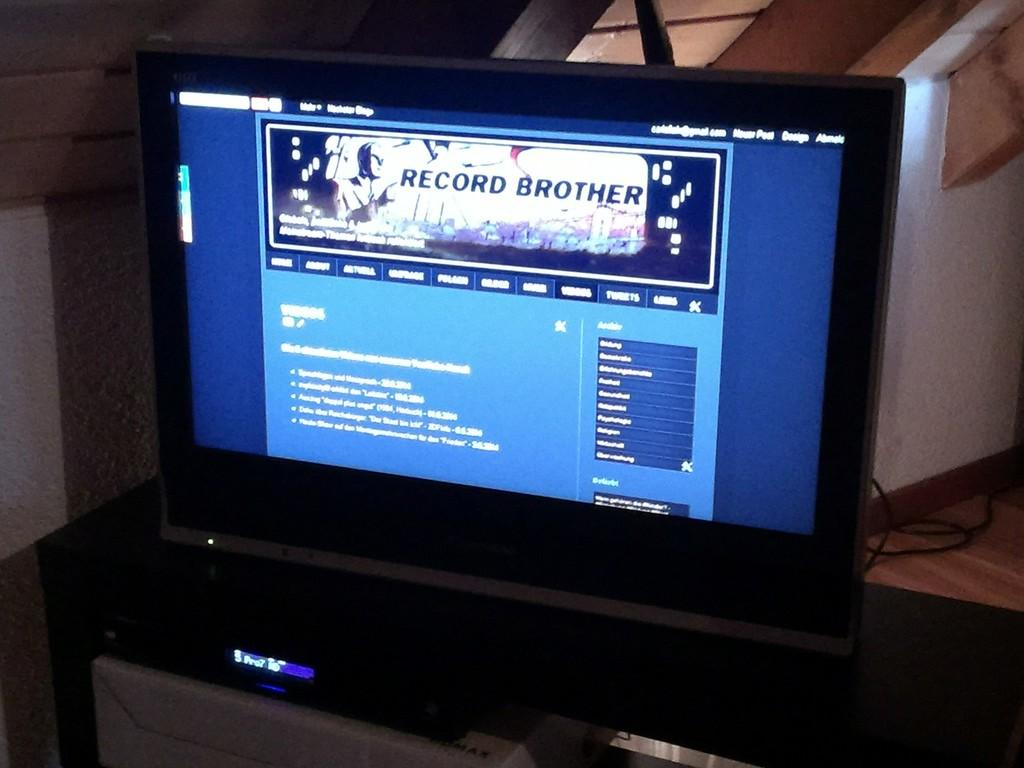<image>
Offer a succinct explanation of the picture presented. A screen displays the homepage of Record Brother. 